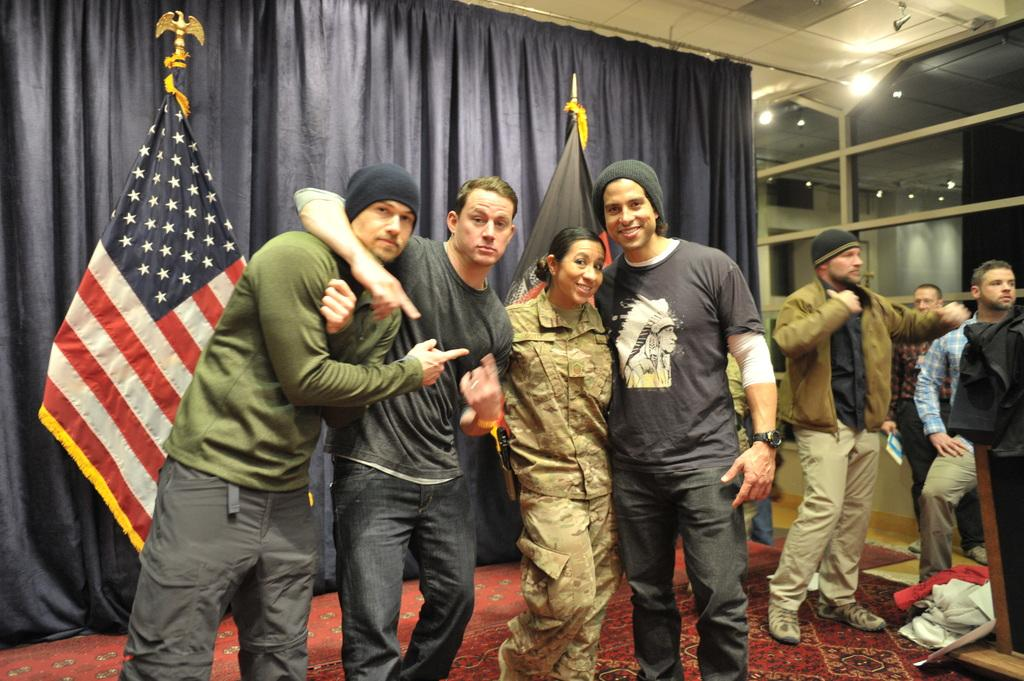What can be seen in the image? There are people standing in the image. What is the color of the curtain in the image? There is a blue color curtain in the image. What is the other object visible in the image? There is a flag in the image. What type of bean is being used to support the flag in the image? There is no bean present in the image, and the flag is not being supported by any bean. 